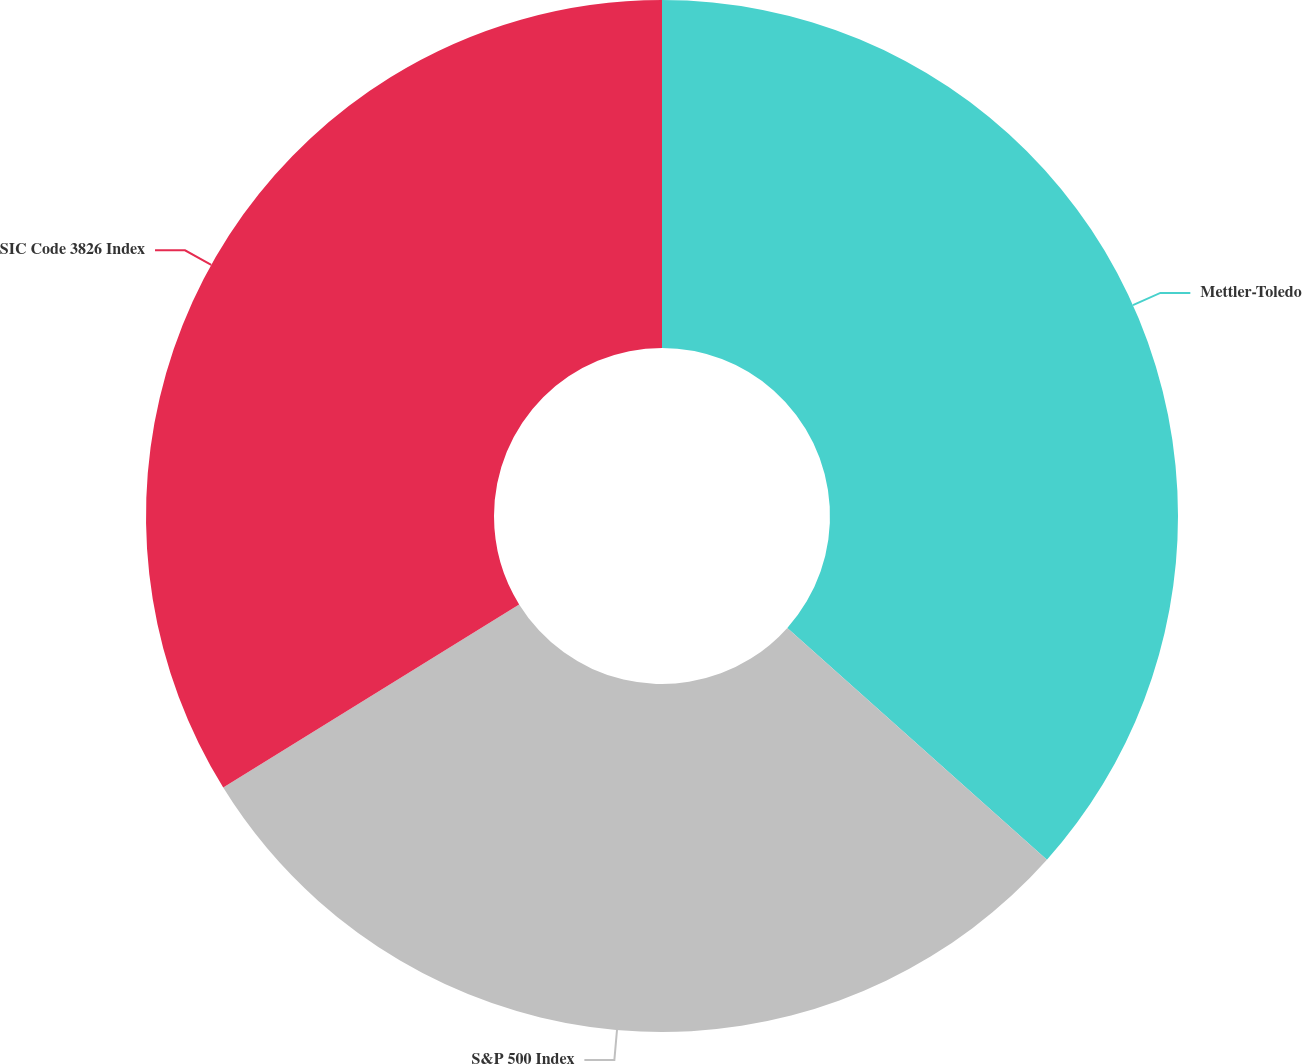Convert chart. <chart><loc_0><loc_0><loc_500><loc_500><pie_chart><fcel>Mettler-Toledo<fcel>S&P 500 Index<fcel>SIC Code 3826 Index<nl><fcel>36.6%<fcel>29.58%<fcel>33.82%<nl></chart> 